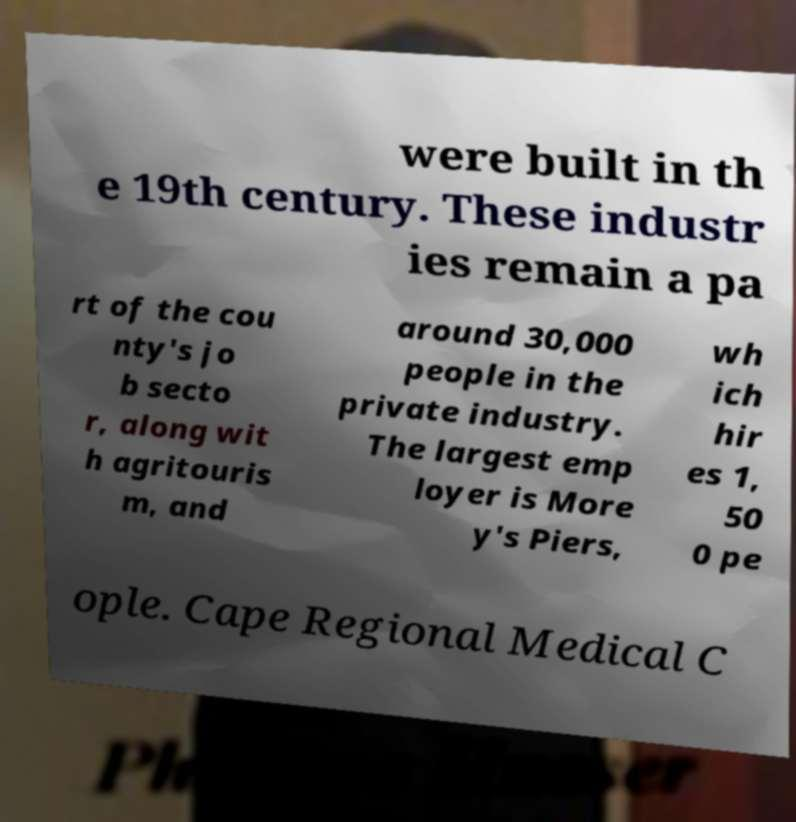What messages or text are displayed in this image? I need them in a readable, typed format. were built in th e 19th century. These industr ies remain a pa rt of the cou nty's jo b secto r, along wit h agritouris m, and around 30,000 people in the private industry. The largest emp loyer is More y's Piers, wh ich hir es 1, 50 0 pe ople. Cape Regional Medical C 